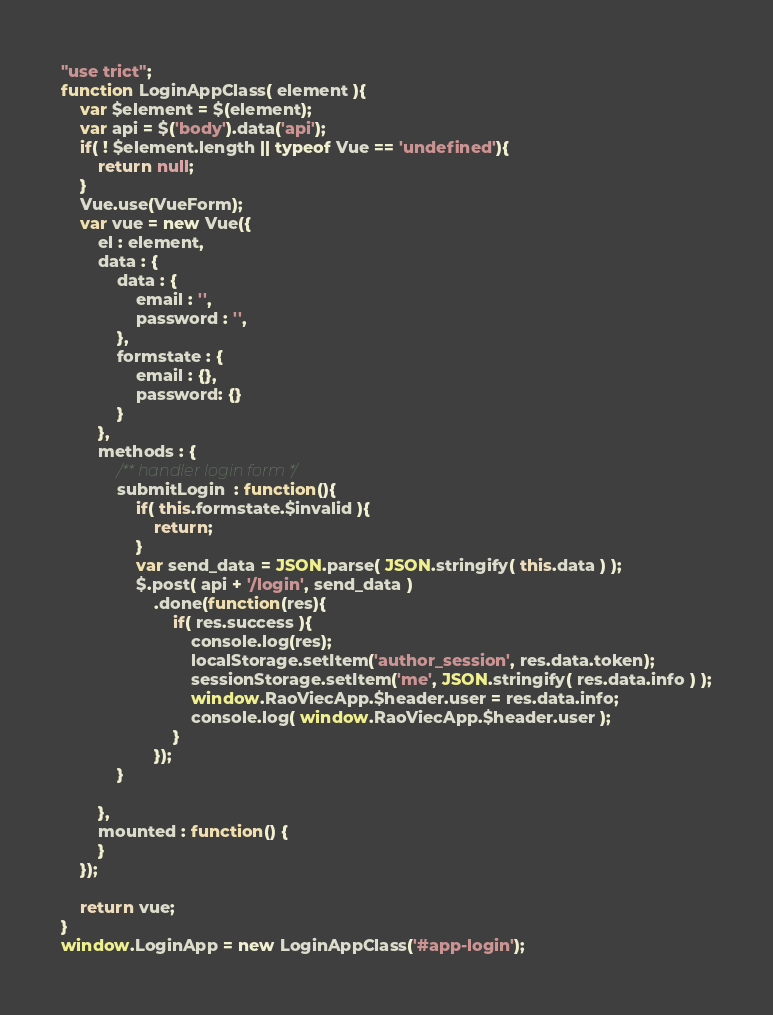<code> <loc_0><loc_0><loc_500><loc_500><_JavaScript_>"use trict";
function LoginAppClass( element ){
    var $element = $(element);
    var api = $('body').data('api');
    if( ! $element.length || typeof Vue == 'undefined'){
        return null;
    }
    Vue.use(VueForm);
    var vue = new Vue({
        el : element,
        data : {
            data : {
                email : '',
                password : '',
            },
            formstate : {
                email : {},
                password: {}
            }
        },
        methods : {
            /** handler login form */
            submitLogin  : function(){
                if( this.formstate.$invalid ){
                    return;
                }
                var send_data = JSON.parse( JSON.stringify( this.data ) );
                $.post( api + '/login', send_data )
                    .done(function(res){
                        if( res.success ){
                            console.log(res);
                            localStorage.setItem('author_session', res.data.token);
                            sessionStorage.setItem('me', JSON.stringify( res.data.info ) );
                            window.RaoViecApp.$header.user = res.data.info;
                            console.log( window.RaoViecApp.$header.user );
                        }
                    });
            }

        },
        mounted : function() {
        }
    });

    return vue;
}
window.LoginApp = new LoginAppClass('#app-login');</code> 